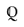Convert formula to latex. <formula><loc_0><loc_0><loc_500><loc_500>\mathbb { Q }</formula> 